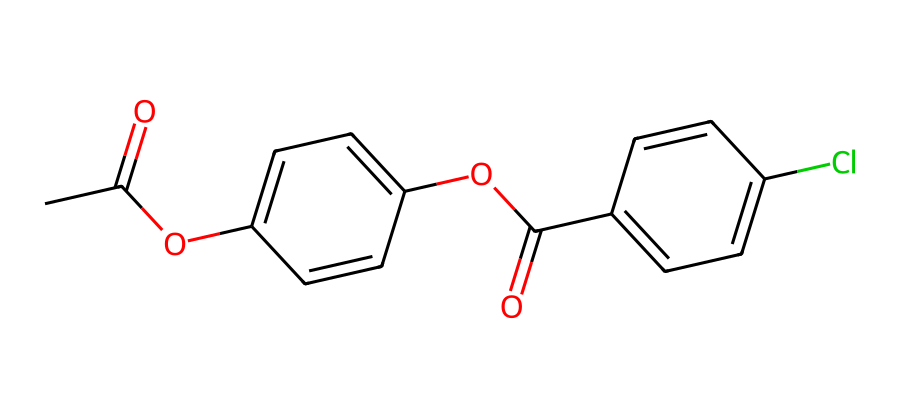What is the molecular formula of the compound? By analyzing the provided SMILES structure, we can identify the atoms involved. The chemical consists of carbon (C), hydrogen (H), oxygen (O), and chlorine (Cl) atoms. Counting the atoms from the SMILES gives us a total of 16 carbons, 14 hydrogens, 4 oxygens, and 1 chlorine, resulting in the molecular formula C16H14ClO4.
Answer: C16H14ClO4 How many aromatic rings are present in this compound? The SMILES representation contains two 'C=C' sequences, which indicate double bonds typically present in aromatic systems. Therefore, the presence of two distinct aromatic structures is noted, giving us a total of two aromatic rings.
Answer: 2 What functional groups can be identified in this molecule? The SMILES shows 'OC(=O)' suggestive of ester groups and 'C=C' indicative of aromaticity. There are also carbonyls in the structure. Thus, the functional groups present include esters and aromatic rings.
Answer: esters and aromatic rings What kind of interactions might this compound exhibit under shear stress? Considering the compound's dilatant nature, it is likely to exhibit shear-thickening behavior, meaning that its viscosity increases with applied stress. The presence of hydrogen bonding and structure possibly contributes to this behavior.
Answer: shear-thickening How might the chlorine substituent affect the properties of this compound? The chlorine substituent can influence properties such as reactivity and solubility due to its electronegative nature. It could also affect the compound's density and intermolecular forces, contributing to its overall behavior as a non-Newtonian fluid.
Answer: reactivity and solubility In what applications could this dilatant compound inspired by historical plague prevention be beneficial? This compound could potentially be used in producing materials that need to withstand fluctuations in stress, such as wound dressings or coatings for protective gear that offer resistance to fluid penetration and microbial activity.
Answer: protective materials 